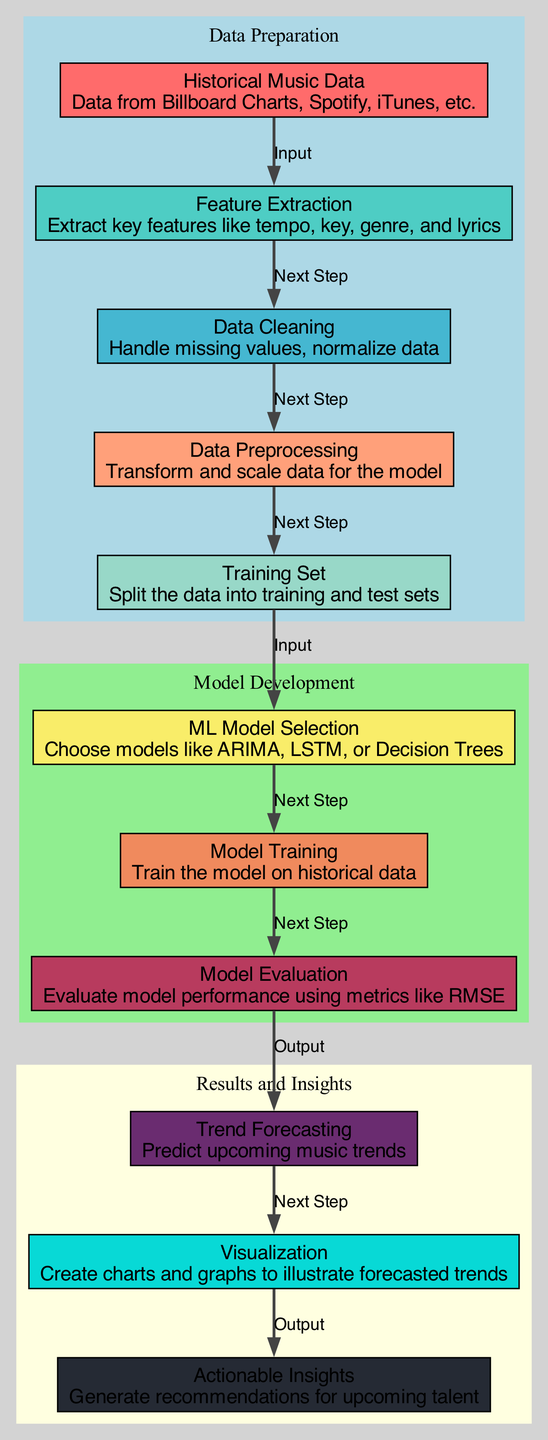What is the first step in the diagram? The first step in the diagram is represented by the "Historical Music Data" node, which serves as the initial input to the process.
Answer: Historical Music Data How many nodes are present in the diagram? The diagram contains a total of eleven nodes, each representing a different stage or component in the trend forecasting process.
Answer: Eleven What edge connects model training to model evaluation? The edge connecting "Model Training" to "Model Evaluation" is labeled as "Next Step," indicating the flow from one process to the next.
Answer: Next Step What type of model selection is indicated in the diagram? The diagram indicates that ML Model Selection involves choosing models like ARIMA, LSTM, or Decision Trees for forecasting.
Answer: ARIMA, LSTM, or Decision Trees Which node generates actionable insights? The node labeled "Actionable Insights" generates the final recommendations based on the visualized trends from the previous nodes in the diagram.
Answer: Actionable Insights What input is required for the ML Model Selection node? The input required for the "ML Model Selection" node is the "Training Set," which has been prepared from the historical data for the model selection process.
Answer: Training Set Which components are included in the "Data Cleaning" phase? The "Data Cleaning" phase focuses on handling missing values and normalizing the data to ensure that it is suitable for further processing.
Answer: Handle missing values, normalize data What output is produced by model evaluation? The output produced by "Model Evaluation" is the performance metrics of the model, such as RMSE, which will influence the trend forecasting.
Answer: RMSE How many subgraphs are used in the diagram? The diagram contains three subgraphs, each representing a distinct phase: Data Preparation, Model Development, and Results and Insights.
Answer: Three 